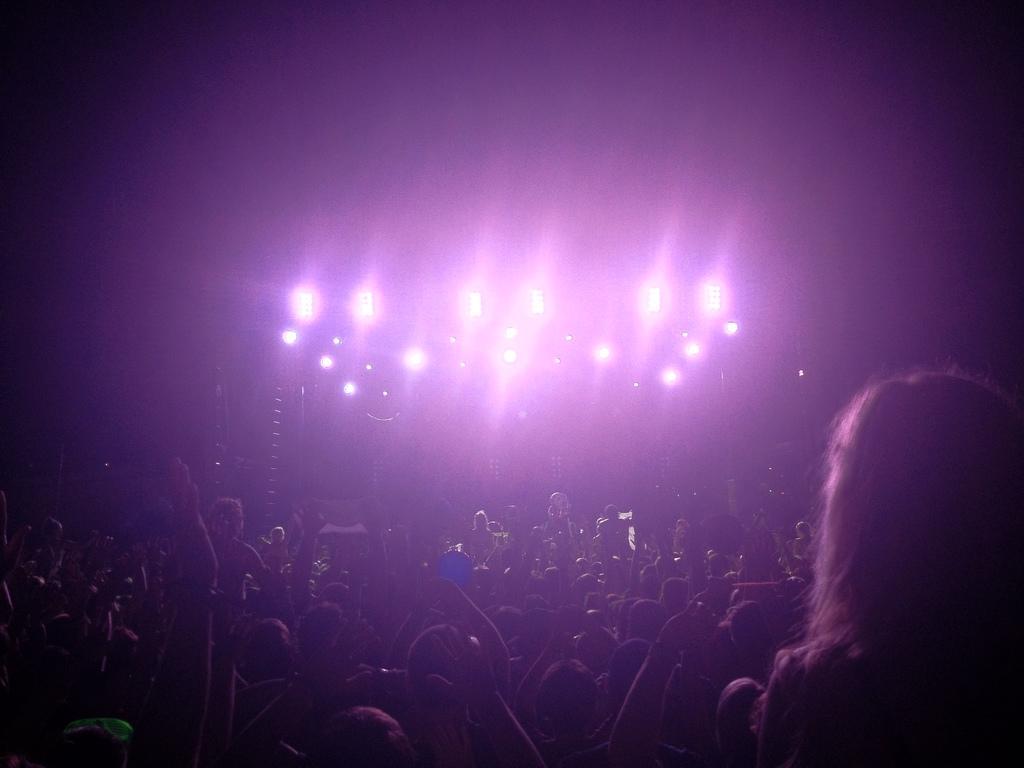Describe this image in one or two sentences. This picture might be taken in a concert in this image at the bottom there are some people who are standing, and on the right side there is one woman and in the center there are some lights. 